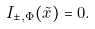<formula> <loc_0><loc_0><loc_500><loc_500>I _ { \pm , \Phi } ( \tilde { x } ) = 0 .</formula> 